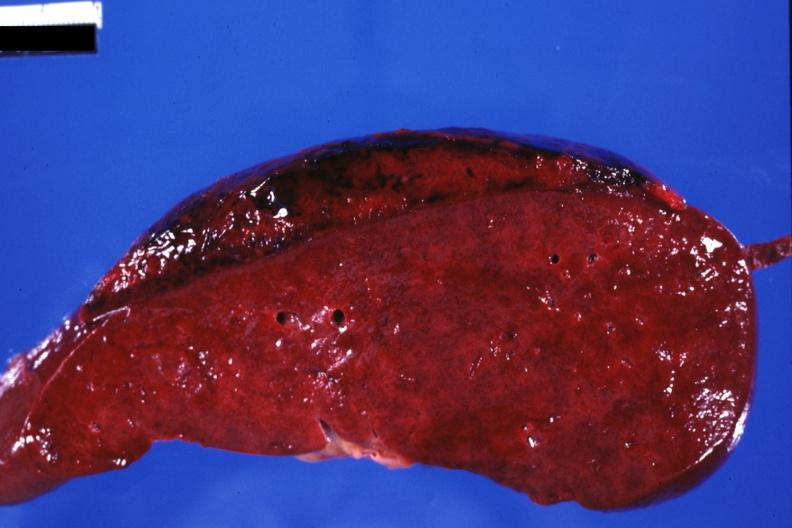what does this image show?
Answer the question using a single word or phrase. Sectioned spleen showing lesion very well 